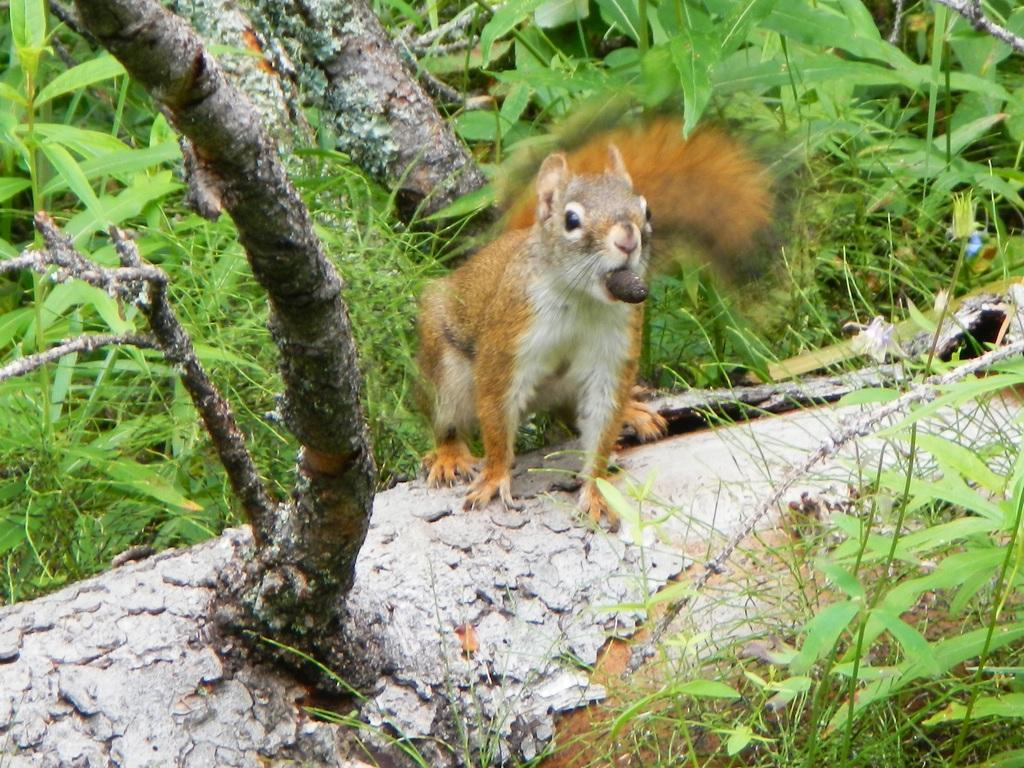What animal can be seen in the image? There is a squirrel in the image. Where is the squirrel located? The squirrel is on a tree. What is the squirrel doing in the image? The squirrel is holding something with its mouth. What type of vegetation is visible in the image? There are leaves visible in the image. What type of brake is visible on the squirrel in the image? There is no brake present on the squirrel in the image. Can you identify any prose written by the squirrel in the image? There is no prose written by the squirrel in the image. 